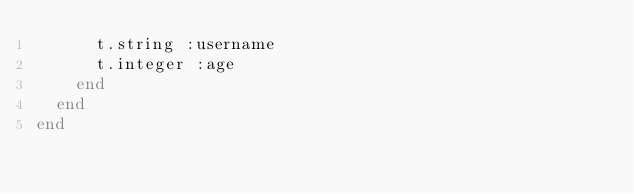Convert code to text. <code><loc_0><loc_0><loc_500><loc_500><_Ruby_>      t.string :username
      t.integer :age
    end
  end
end
</code> 